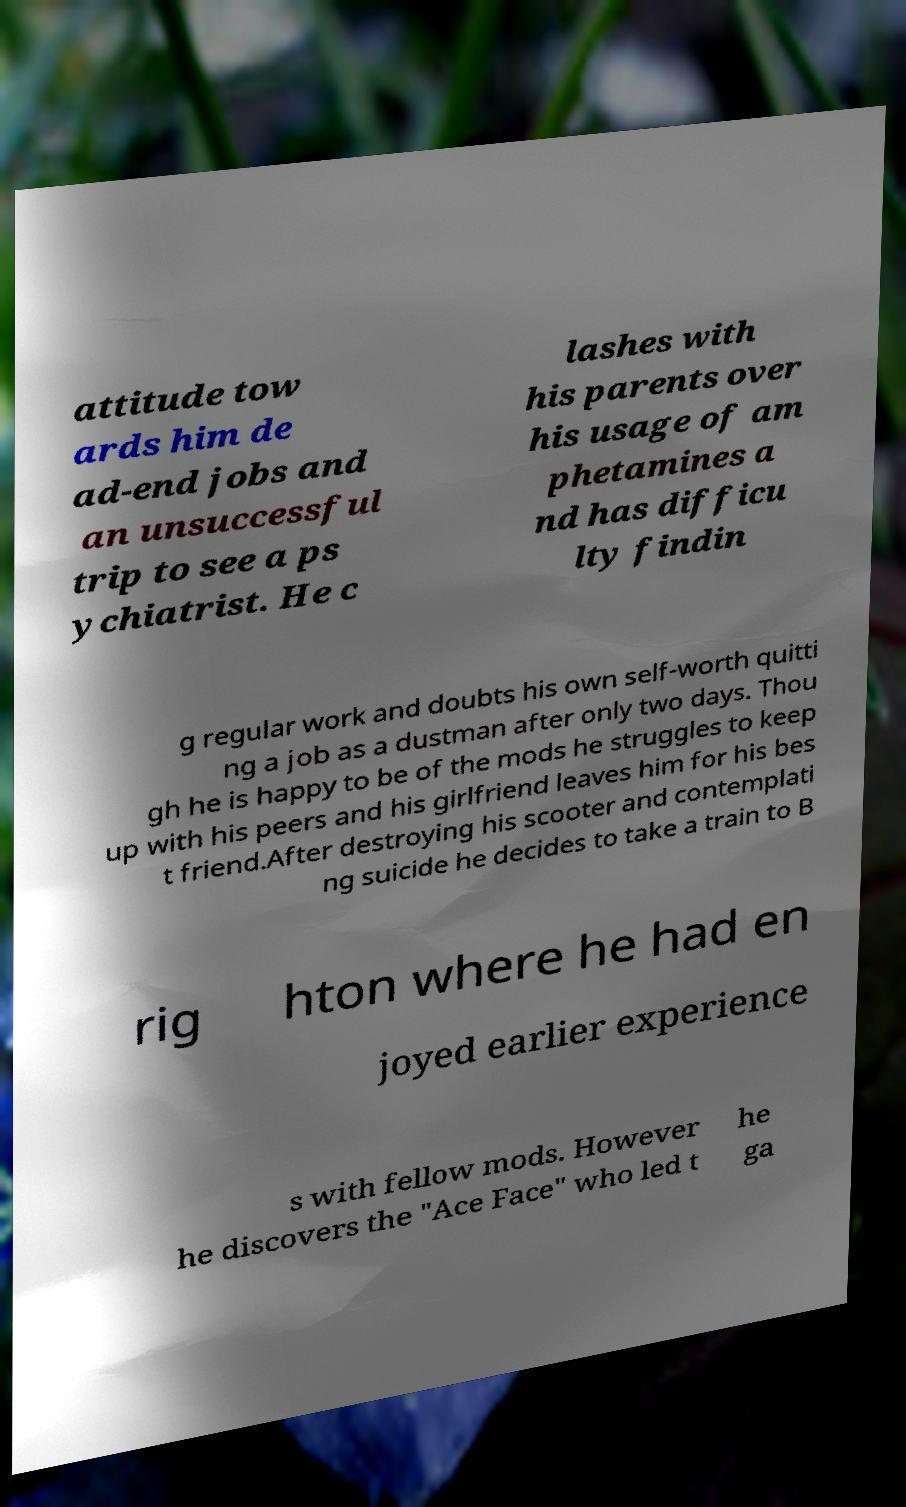Could you assist in decoding the text presented in this image and type it out clearly? attitude tow ards him de ad-end jobs and an unsuccessful trip to see a ps ychiatrist. He c lashes with his parents over his usage of am phetamines a nd has difficu lty findin g regular work and doubts his own self-worth quitti ng a job as a dustman after only two days. Thou gh he is happy to be of the mods he struggles to keep up with his peers and his girlfriend leaves him for his bes t friend.After destroying his scooter and contemplati ng suicide he decides to take a train to B rig hton where he had en joyed earlier experience s with fellow mods. However he discovers the "Ace Face" who led t he ga 